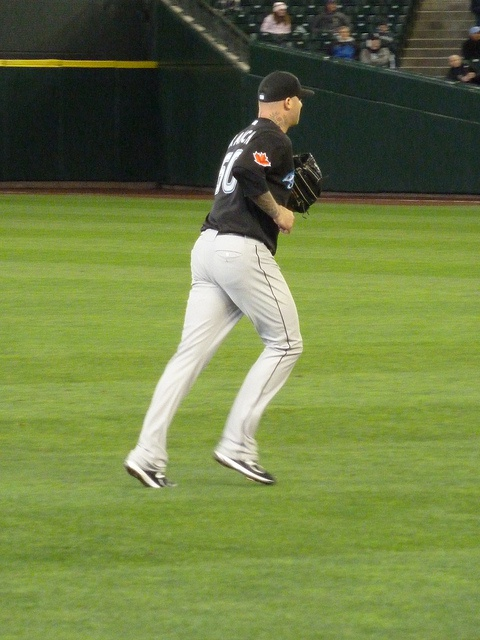Describe the objects in this image and their specific colors. I can see people in black, lightgray, olive, and darkgray tones, baseball glove in black, gray, darkgreen, and darkgray tones, people in black, darkgray, gray, and maroon tones, people in black and gray tones, and people in black, navy, darkblue, and gray tones in this image. 